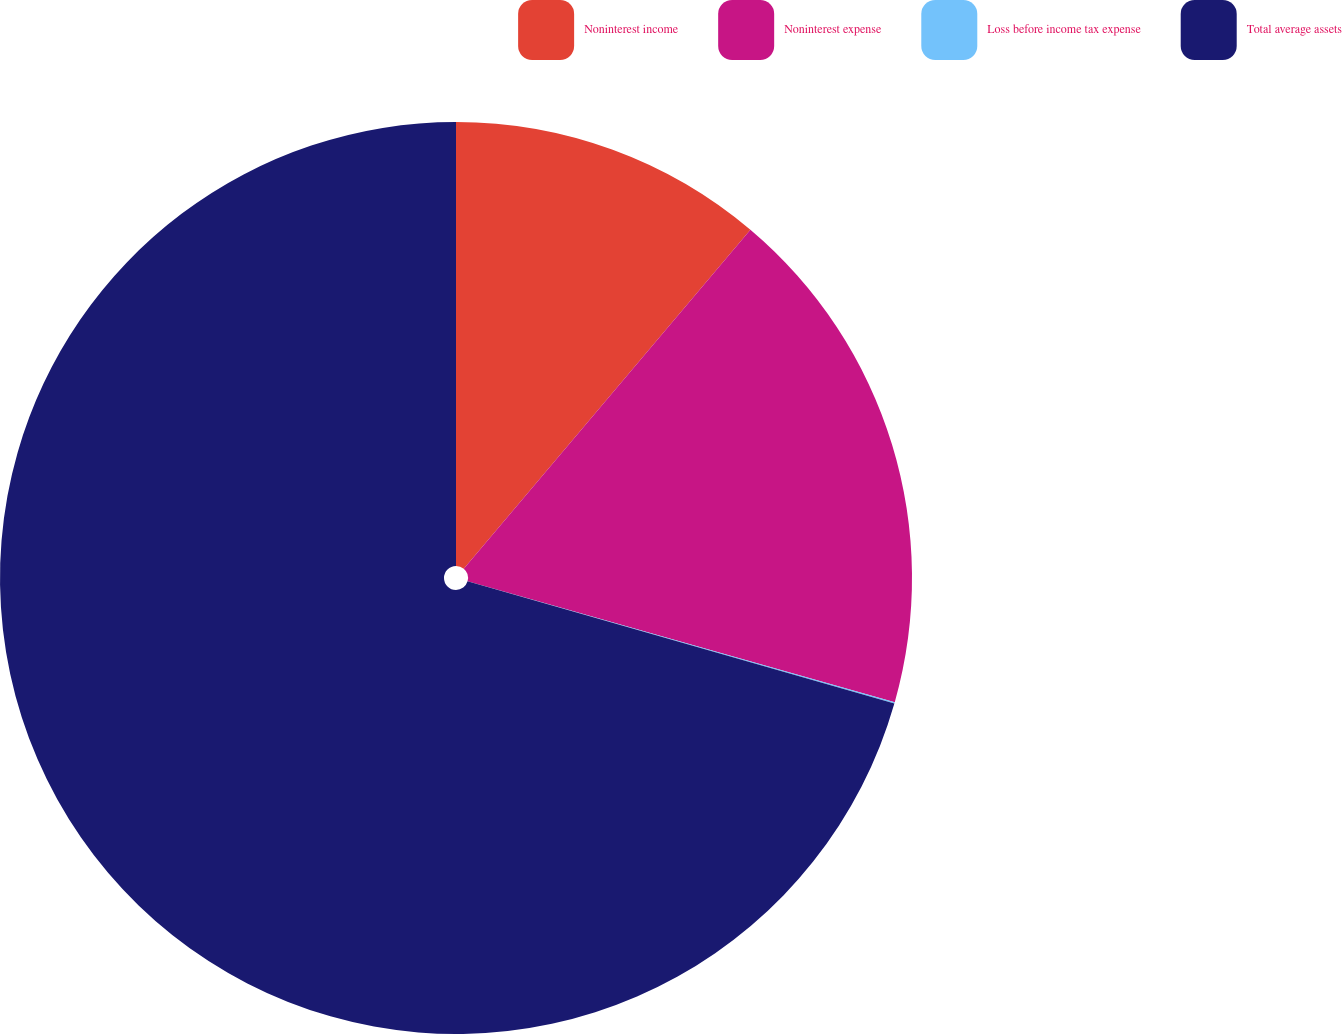Convert chart. <chart><loc_0><loc_0><loc_500><loc_500><pie_chart><fcel>Noninterest income<fcel>Noninterest expense<fcel>Loss before income tax expense<fcel>Total average assets<nl><fcel>11.17%<fcel>18.22%<fcel>0.05%<fcel>70.56%<nl></chart> 